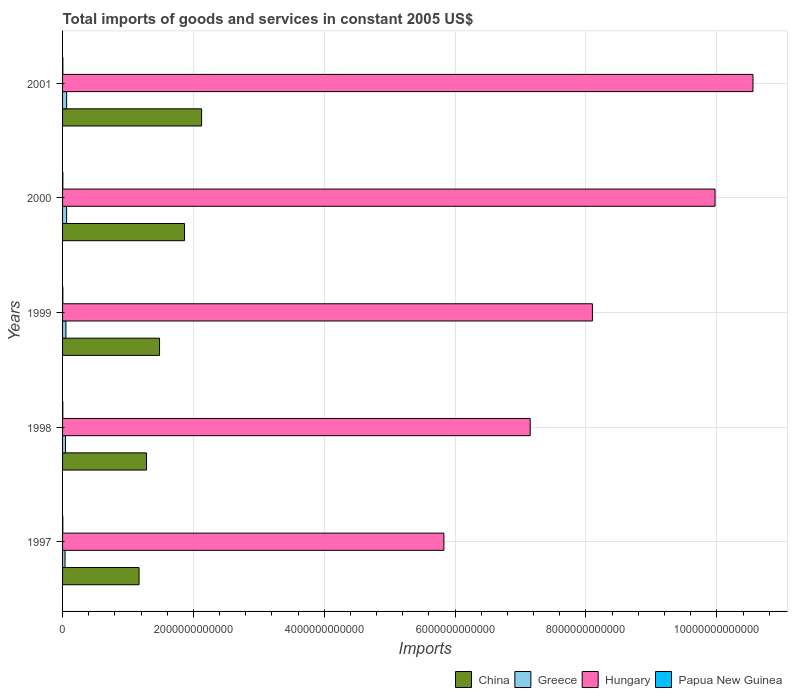How many different coloured bars are there?
Ensure brevity in your answer.  4. Are the number of bars on each tick of the Y-axis equal?
Offer a terse response. Yes. How many bars are there on the 2nd tick from the top?
Offer a very short reply. 4. How many bars are there on the 3rd tick from the bottom?
Ensure brevity in your answer.  4. What is the label of the 5th group of bars from the top?
Give a very brief answer. 1997. In how many cases, is the number of bars for a given year not equal to the number of legend labels?
Provide a short and direct response. 0. What is the total imports of goods and services in Greece in 2000?
Keep it short and to the point. 6.17e+1. Across all years, what is the maximum total imports of goods and services in Papua New Guinea?
Your response must be concise. 4.48e+09. Across all years, what is the minimum total imports of goods and services in Greece?
Provide a short and direct response. 3.80e+1. In which year was the total imports of goods and services in China maximum?
Make the answer very short. 2001. What is the total total imports of goods and services in Greece in the graph?
Your response must be concise. 2.58e+11. What is the difference between the total imports of goods and services in Papua New Guinea in 1998 and that in 2000?
Give a very brief answer. -3.27e+08. What is the difference between the total imports of goods and services in Papua New Guinea in 1998 and the total imports of goods and services in China in 2001?
Your response must be concise. -2.12e+12. What is the average total imports of goods and services in China per year?
Make the answer very short. 1.58e+12. In the year 2000, what is the difference between the total imports of goods and services in Hungary and total imports of goods and services in Greece?
Your response must be concise. 9.91e+12. What is the ratio of the total imports of goods and services in Hungary in 1999 to that in 2000?
Provide a short and direct response. 0.81. Is the total imports of goods and services in Papua New Guinea in 1998 less than that in 1999?
Provide a short and direct response. Yes. What is the difference between the highest and the second highest total imports of goods and services in Greece?
Offer a terse response. 6.12e+08. What is the difference between the highest and the lowest total imports of goods and services in Hungary?
Keep it short and to the point. 4.72e+12. Is it the case that in every year, the sum of the total imports of goods and services in Hungary and total imports of goods and services in Papua New Guinea is greater than the sum of total imports of goods and services in China and total imports of goods and services in Greece?
Provide a short and direct response. Yes. What does the 2nd bar from the top in 2001 represents?
Provide a succinct answer. Hungary. How many bars are there?
Your answer should be compact. 20. Are all the bars in the graph horizontal?
Give a very brief answer. Yes. How many years are there in the graph?
Offer a terse response. 5. What is the difference between two consecutive major ticks on the X-axis?
Make the answer very short. 2.00e+12. What is the title of the graph?
Ensure brevity in your answer.  Total imports of goods and services in constant 2005 US$. What is the label or title of the X-axis?
Your answer should be very brief. Imports. What is the Imports of China in 1997?
Your response must be concise. 1.17e+12. What is the Imports of Greece in 1997?
Keep it short and to the point. 3.80e+1. What is the Imports in Hungary in 1997?
Ensure brevity in your answer.  5.83e+12. What is the Imports in Papua New Guinea in 1997?
Your response must be concise. 3.80e+09. What is the Imports of China in 1998?
Ensure brevity in your answer.  1.28e+12. What is the Imports in Greece in 1998?
Provide a succinct answer. 4.49e+1. What is the Imports in Hungary in 1998?
Make the answer very short. 7.15e+12. What is the Imports in Papua New Guinea in 1998?
Keep it short and to the point. 3.81e+09. What is the Imports of China in 1999?
Make the answer very short. 1.48e+12. What is the Imports of Greece in 1999?
Your response must be concise. 5.14e+1. What is the Imports in Hungary in 1999?
Your answer should be compact. 8.10e+12. What is the Imports of Papua New Guinea in 1999?
Make the answer very short. 4.34e+09. What is the Imports of China in 2000?
Keep it short and to the point. 1.86e+12. What is the Imports of Greece in 2000?
Give a very brief answer. 6.17e+1. What is the Imports of Hungary in 2000?
Your answer should be very brief. 9.97e+12. What is the Imports in Papua New Guinea in 2000?
Offer a terse response. 4.14e+09. What is the Imports of China in 2001?
Your response must be concise. 2.13e+12. What is the Imports of Greece in 2001?
Give a very brief answer. 6.24e+1. What is the Imports in Hungary in 2001?
Make the answer very short. 1.06e+13. What is the Imports in Papua New Guinea in 2001?
Offer a terse response. 4.48e+09. Across all years, what is the maximum Imports of China?
Provide a short and direct response. 2.13e+12. Across all years, what is the maximum Imports in Greece?
Your answer should be compact. 6.24e+1. Across all years, what is the maximum Imports of Hungary?
Give a very brief answer. 1.06e+13. Across all years, what is the maximum Imports in Papua New Guinea?
Your answer should be very brief. 4.48e+09. Across all years, what is the minimum Imports in China?
Give a very brief answer. 1.17e+12. Across all years, what is the minimum Imports of Greece?
Make the answer very short. 3.80e+1. Across all years, what is the minimum Imports of Hungary?
Your response must be concise. 5.83e+12. Across all years, what is the minimum Imports in Papua New Guinea?
Provide a short and direct response. 3.80e+09. What is the total Imports of China in the graph?
Make the answer very short. 7.92e+12. What is the total Imports in Greece in the graph?
Provide a short and direct response. 2.58e+11. What is the total Imports in Hungary in the graph?
Ensure brevity in your answer.  4.16e+13. What is the total Imports of Papua New Guinea in the graph?
Your answer should be compact. 2.06e+1. What is the difference between the Imports in China in 1997 and that in 1998?
Make the answer very short. -1.14e+11. What is the difference between the Imports in Greece in 1997 and that in 1998?
Give a very brief answer. -6.90e+09. What is the difference between the Imports of Hungary in 1997 and that in 1998?
Your response must be concise. -1.32e+12. What is the difference between the Imports of Papua New Guinea in 1997 and that in 1998?
Your answer should be compact. -1.46e+07. What is the difference between the Imports in China in 1997 and that in 1999?
Ensure brevity in your answer.  -3.13e+11. What is the difference between the Imports in Greece in 1997 and that in 1999?
Make the answer very short. -1.34e+1. What is the difference between the Imports in Hungary in 1997 and that in 1999?
Your response must be concise. -2.27e+12. What is the difference between the Imports of Papua New Guinea in 1997 and that in 1999?
Give a very brief answer. -5.48e+08. What is the difference between the Imports in China in 1997 and that in 2000?
Make the answer very short. -6.94e+11. What is the difference between the Imports in Greece in 1997 and that in 2000?
Offer a terse response. -2.38e+1. What is the difference between the Imports in Hungary in 1997 and that in 2000?
Provide a succinct answer. -4.14e+12. What is the difference between the Imports in Papua New Guinea in 1997 and that in 2000?
Provide a short and direct response. -3.42e+08. What is the difference between the Imports of China in 1997 and that in 2001?
Offer a very short reply. -9.56e+11. What is the difference between the Imports of Greece in 1997 and that in 2001?
Ensure brevity in your answer.  -2.44e+1. What is the difference between the Imports in Hungary in 1997 and that in 2001?
Make the answer very short. -4.72e+12. What is the difference between the Imports of Papua New Guinea in 1997 and that in 2001?
Offer a terse response. -6.84e+08. What is the difference between the Imports in China in 1998 and that in 1999?
Your answer should be compact. -1.99e+11. What is the difference between the Imports in Greece in 1998 and that in 1999?
Make the answer very short. -6.50e+09. What is the difference between the Imports in Hungary in 1998 and that in 1999?
Offer a very short reply. -9.51e+11. What is the difference between the Imports of Papua New Guinea in 1998 and that in 1999?
Provide a succinct answer. -5.34e+08. What is the difference between the Imports of China in 1998 and that in 2000?
Provide a short and direct response. -5.80e+11. What is the difference between the Imports in Greece in 1998 and that in 2000?
Provide a succinct answer. -1.69e+1. What is the difference between the Imports of Hungary in 1998 and that in 2000?
Give a very brief answer. -2.83e+12. What is the difference between the Imports in Papua New Guinea in 1998 and that in 2000?
Give a very brief answer. -3.27e+08. What is the difference between the Imports of China in 1998 and that in 2001?
Give a very brief answer. -8.42e+11. What is the difference between the Imports of Greece in 1998 and that in 2001?
Ensure brevity in your answer.  -1.75e+1. What is the difference between the Imports in Hungary in 1998 and that in 2001?
Make the answer very short. -3.41e+12. What is the difference between the Imports in Papua New Guinea in 1998 and that in 2001?
Offer a very short reply. -6.70e+08. What is the difference between the Imports of China in 1999 and that in 2000?
Make the answer very short. -3.82e+11. What is the difference between the Imports of Greece in 1999 and that in 2000?
Offer a very short reply. -1.04e+1. What is the difference between the Imports in Hungary in 1999 and that in 2000?
Provide a succinct answer. -1.87e+12. What is the difference between the Imports of Papua New Guinea in 1999 and that in 2000?
Keep it short and to the point. 2.06e+08. What is the difference between the Imports of China in 1999 and that in 2001?
Offer a terse response. -6.43e+11. What is the difference between the Imports in Greece in 1999 and that in 2001?
Your answer should be very brief. -1.10e+1. What is the difference between the Imports of Hungary in 1999 and that in 2001?
Offer a very short reply. -2.45e+12. What is the difference between the Imports in Papua New Guinea in 1999 and that in 2001?
Offer a terse response. -1.36e+08. What is the difference between the Imports in China in 2000 and that in 2001?
Offer a terse response. -2.61e+11. What is the difference between the Imports of Greece in 2000 and that in 2001?
Offer a terse response. -6.12e+08. What is the difference between the Imports of Hungary in 2000 and that in 2001?
Make the answer very short. -5.80e+11. What is the difference between the Imports in Papua New Guinea in 2000 and that in 2001?
Provide a short and direct response. -3.42e+08. What is the difference between the Imports in China in 1997 and the Imports in Greece in 1998?
Your answer should be very brief. 1.12e+12. What is the difference between the Imports in China in 1997 and the Imports in Hungary in 1998?
Provide a succinct answer. -5.98e+12. What is the difference between the Imports of China in 1997 and the Imports of Papua New Guinea in 1998?
Provide a short and direct response. 1.17e+12. What is the difference between the Imports in Greece in 1997 and the Imports in Hungary in 1998?
Ensure brevity in your answer.  -7.11e+12. What is the difference between the Imports in Greece in 1997 and the Imports in Papua New Guinea in 1998?
Your answer should be compact. 3.42e+1. What is the difference between the Imports of Hungary in 1997 and the Imports of Papua New Guinea in 1998?
Your response must be concise. 5.82e+12. What is the difference between the Imports of China in 1997 and the Imports of Greece in 1999?
Provide a succinct answer. 1.12e+12. What is the difference between the Imports of China in 1997 and the Imports of Hungary in 1999?
Offer a very short reply. -6.93e+12. What is the difference between the Imports of China in 1997 and the Imports of Papua New Guinea in 1999?
Offer a terse response. 1.17e+12. What is the difference between the Imports of Greece in 1997 and the Imports of Hungary in 1999?
Give a very brief answer. -8.06e+12. What is the difference between the Imports in Greece in 1997 and the Imports in Papua New Guinea in 1999?
Offer a terse response. 3.36e+1. What is the difference between the Imports in Hungary in 1997 and the Imports in Papua New Guinea in 1999?
Ensure brevity in your answer.  5.82e+12. What is the difference between the Imports of China in 1997 and the Imports of Greece in 2000?
Your answer should be compact. 1.11e+12. What is the difference between the Imports in China in 1997 and the Imports in Hungary in 2000?
Offer a terse response. -8.80e+12. What is the difference between the Imports in China in 1997 and the Imports in Papua New Guinea in 2000?
Offer a very short reply. 1.17e+12. What is the difference between the Imports of Greece in 1997 and the Imports of Hungary in 2000?
Your answer should be very brief. -9.93e+12. What is the difference between the Imports in Greece in 1997 and the Imports in Papua New Guinea in 2000?
Provide a short and direct response. 3.38e+1. What is the difference between the Imports of Hungary in 1997 and the Imports of Papua New Guinea in 2000?
Your answer should be compact. 5.82e+12. What is the difference between the Imports of China in 1997 and the Imports of Greece in 2001?
Offer a very short reply. 1.11e+12. What is the difference between the Imports of China in 1997 and the Imports of Hungary in 2001?
Your answer should be compact. -9.38e+12. What is the difference between the Imports of China in 1997 and the Imports of Papua New Guinea in 2001?
Your response must be concise. 1.17e+12. What is the difference between the Imports in Greece in 1997 and the Imports in Hungary in 2001?
Ensure brevity in your answer.  -1.05e+13. What is the difference between the Imports of Greece in 1997 and the Imports of Papua New Guinea in 2001?
Your response must be concise. 3.35e+1. What is the difference between the Imports in Hungary in 1997 and the Imports in Papua New Guinea in 2001?
Ensure brevity in your answer.  5.82e+12. What is the difference between the Imports of China in 1998 and the Imports of Greece in 1999?
Make the answer very short. 1.23e+12. What is the difference between the Imports in China in 1998 and the Imports in Hungary in 1999?
Offer a very short reply. -6.81e+12. What is the difference between the Imports of China in 1998 and the Imports of Papua New Guinea in 1999?
Offer a terse response. 1.28e+12. What is the difference between the Imports in Greece in 1998 and the Imports in Hungary in 1999?
Make the answer very short. -8.05e+12. What is the difference between the Imports in Greece in 1998 and the Imports in Papua New Guinea in 1999?
Ensure brevity in your answer.  4.05e+1. What is the difference between the Imports of Hungary in 1998 and the Imports of Papua New Guinea in 1999?
Provide a succinct answer. 7.14e+12. What is the difference between the Imports in China in 1998 and the Imports in Greece in 2000?
Offer a terse response. 1.22e+12. What is the difference between the Imports of China in 1998 and the Imports of Hungary in 2000?
Ensure brevity in your answer.  -8.69e+12. What is the difference between the Imports in China in 1998 and the Imports in Papua New Guinea in 2000?
Your response must be concise. 1.28e+12. What is the difference between the Imports in Greece in 1998 and the Imports in Hungary in 2000?
Your answer should be compact. -9.93e+12. What is the difference between the Imports in Greece in 1998 and the Imports in Papua New Guinea in 2000?
Your response must be concise. 4.07e+1. What is the difference between the Imports in Hungary in 1998 and the Imports in Papua New Guinea in 2000?
Make the answer very short. 7.14e+12. What is the difference between the Imports in China in 1998 and the Imports in Greece in 2001?
Make the answer very short. 1.22e+12. What is the difference between the Imports of China in 1998 and the Imports of Hungary in 2001?
Your answer should be very brief. -9.27e+12. What is the difference between the Imports in China in 1998 and the Imports in Papua New Guinea in 2001?
Offer a terse response. 1.28e+12. What is the difference between the Imports of Greece in 1998 and the Imports of Hungary in 2001?
Give a very brief answer. -1.05e+13. What is the difference between the Imports in Greece in 1998 and the Imports in Papua New Guinea in 2001?
Offer a very short reply. 4.04e+1. What is the difference between the Imports of Hungary in 1998 and the Imports of Papua New Guinea in 2001?
Keep it short and to the point. 7.14e+12. What is the difference between the Imports of China in 1999 and the Imports of Greece in 2000?
Offer a terse response. 1.42e+12. What is the difference between the Imports in China in 1999 and the Imports in Hungary in 2000?
Provide a succinct answer. -8.49e+12. What is the difference between the Imports in China in 1999 and the Imports in Papua New Guinea in 2000?
Keep it short and to the point. 1.48e+12. What is the difference between the Imports in Greece in 1999 and the Imports in Hungary in 2000?
Your response must be concise. -9.92e+12. What is the difference between the Imports of Greece in 1999 and the Imports of Papua New Guinea in 2000?
Keep it short and to the point. 4.72e+1. What is the difference between the Imports of Hungary in 1999 and the Imports of Papua New Guinea in 2000?
Give a very brief answer. 8.09e+12. What is the difference between the Imports in China in 1999 and the Imports in Greece in 2001?
Keep it short and to the point. 1.42e+12. What is the difference between the Imports in China in 1999 and the Imports in Hungary in 2001?
Your answer should be compact. -9.07e+12. What is the difference between the Imports in China in 1999 and the Imports in Papua New Guinea in 2001?
Give a very brief answer. 1.48e+12. What is the difference between the Imports of Greece in 1999 and the Imports of Hungary in 2001?
Give a very brief answer. -1.05e+13. What is the difference between the Imports in Greece in 1999 and the Imports in Papua New Guinea in 2001?
Keep it short and to the point. 4.69e+1. What is the difference between the Imports of Hungary in 1999 and the Imports of Papua New Guinea in 2001?
Your answer should be very brief. 8.09e+12. What is the difference between the Imports of China in 2000 and the Imports of Greece in 2001?
Ensure brevity in your answer.  1.80e+12. What is the difference between the Imports of China in 2000 and the Imports of Hungary in 2001?
Make the answer very short. -8.69e+12. What is the difference between the Imports in China in 2000 and the Imports in Papua New Guinea in 2001?
Make the answer very short. 1.86e+12. What is the difference between the Imports of Greece in 2000 and the Imports of Hungary in 2001?
Keep it short and to the point. -1.05e+13. What is the difference between the Imports of Greece in 2000 and the Imports of Papua New Guinea in 2001?
Provide a short and direct response. 5.73e+1. What is the difference between the Imports of Hungary in 2000 and the Imports of Papua New Guinea in 2001?
Your answer should be very brief. 9.97e+12. What is the average Imports in China per year?
Your answer should be compact. 1.58e+12. What is the average Imports of Greece per year?
Offer a very short reply. 5.17e+1. What is the average Imports of Hungary per year?
Keep it short and to the point. 8.32e+12. What is the average Imports in Papua New Guinea per year?
Your answer should be compact. 4.11e+09. In the year 1997, what is the difference between the Imports of China and Imports of Greece?
Provide a short and direct response. 1.13e+12. In the year 1997, what is the difference between the Imports in China and Imports in Hungary?
Your answer should be very brief. -4.66e+12. In the year 1997, what is the difference between the Imports of China and Imports of Papua New Guinea?
Make the answer very short. 1.17e+12. In the year 1997, what is the difference between the Imports in Greece and Imports in Hungary?
Keep it short and to the point. -5.79e+12. In the year 1997, what is the difference between the Imports of Greece and Imports of Papua New Guinea?
Provide a short and direct response. 3.42e+1. In the year 1997, what is the difference between the Imports of Hungary and Imports of Papua New Guinea?
Offer a very short reply. 5.82e+12. In the year 1998, what is the difference between the Imports of China and Imports of Greece?
Offer a very short reply. 1.24e+12. In the year 1998, what is the difference between the Imports of China and Imports of Hungary?
Make the answer very short. -5.86e+12. In the year 1998, what is the difference between the Imports in China and Imports in Papua New Guinea?
Your answer should be compact. 1.28e+12. In the year 1998, what is the difference between the Imports of Greece and Imports of Hungary?
Make the answer very short. -7.10e+12. In the year 1998, what is the difference between the Imports of Greece and Imports of Papua New Guinea?
Provide a succinct answer. 4.11e+1. In the year 1998, what is the difference between the Imports in Hungary and Imports in Papua New Guinea?
Keep it short and to the point. 7.14e+12. In the year 1999, what is the difference between the Imports of China and Imports of Greece?
Your answer should be compact. 1.43e+12. In the year 1999, what is the difference between the Imports in China and Imports in Hungary?
Your answer should be compact. -6.62e+12. In the year 1999, what is the difference between the Imports of China and Imports of Papua New Guinea?
Provide a succinct answer. 1.48e+12. In the year 1999, what is the difference between the Imports of Greece and Imports of Hungary?
Make the answer very short. -8.05e+12. In the year 1999, what is the difference between the Imports in Greece and Imports in Papua New Guinea?
Offer a terse response. 4.70e+1. In the year 1999, what is the difference between the Imports in Hungary and Imports in Papua New Guinea?
Your answer should be very brief. 8.09e+12. In the year 2000, what is the difference between the Imports in China and Imports in Greece?
Make the answer very short. 1.80e+12. In the year 2000, what is the difference between the Imports of China and Imports of Hungary?
Give a very brief answer. -8.11e+12. In the year 2000, what is the difference between the Imports in China and Imports in Papua New Guinea?
Give a very brief answer. 1.86e+12. In the year 2000, what is the difference between the Imports in Greece and Imports in Hungary?
Give a very brief answer. -9.91e+12. In the year 2000, what is the difference between the Imports in Greece and Imports in Papua New Guinea?
Ensure brevity in your answer.  5.76e+1. In the year 2000, what is the difference between the Imports of Hungary and Imports of Papua New Guinea?
Your response must be concise. 9.97e+12. In the year 2001, what is the difference between the Imports of China and Imports of Greece?
Provide a succinct answer. 2.06e+12. In the year 2001, what is the difference between the Imports of China and Imports of Hungary?
Offer a terse response. -8.43e+12. In the year 2001, what is the difference between the Imports of China and Imports of Papua New Guinea?
Your response must be concise. 2.12e+12. In the year 2001, what is the difference between the Imports in Greece and Imports in Hungary?
Offer a very short reply. -1.05e+13. In the year 2001, what is the difference between the Imports of Greece and Imports of Papua New Guinea?
Ensure brevity in your answer.  5.79e+1. In the year 2001, what is the difference between the Imports in Hungary and Imports in Papua New Guinea?
Your answer should be compact. 1.05e+13. What is the ratio of the Imports of China in 1997 to that in 1998?
Offer a terse response. 0.91. What is the ratio of the Imports of Greece in 1997 to that in 1998?
Ensure brevity in your answer.  0.85. What is the ratio of the Imports in Hungary in 1997 to that in 1998?
Offer a terse response. 0.82. What is the ratio of the Imports of China in 1997 to that in 1999?
Your response must be concise. 0.79. What is the ratio of the Imports in Greece in 1997 to that in 1999?
Your answer should be very brief. 0.74. What is the ratio of the Imports of Hungary in 1997 to that in 1999?
Your answer should be compact. 0.72. What is the ratio of the Imports in Papua New Guinea in 1997 to that in 1999?
Give a very brief answer. 0.87. What is the ratio of the Imports in China in 1997 to that in 2000?
Provide a succinct answer. 0.63. What is the ratio of the Imports in Greece in 1997 to that in 2000?
Provide a short and direct response. 0.62. What is the ratio of the Imports in Hungary in 1997 to that in 2000?
Your answer should be very brief. 0.58. What is the ratio of the Imports in Papua New Guinea in 1997 to that in 2000?
Give a very brief answer. 0.92. What is the ratio of the Imports of China in 1997 to that in 2001?
Offer a very short reply. 0.55. What is the ratio of the Imports of Greece in 1997 to that in 2001?
Give a very brief answer. 0.61. What is the ratio of the Imports in Hungary in 1997 to that in 2001?
Make the answer very short. 0.55. What is the ratio of the Imports in Papua New Guinea in 1997 to that in 2001?
Keep it short and to the point. 0.85. What is the ratio of the Imports of China in 1998 to that in 1999?
Give a very brief answer. 0.87. What is the ratio of the Imports in Greece in 1998 to that in 1999?
Keep it short and to the point. 0.87. What is the ratio of the Imports of Hungary in 1998 to that in 1999?
Provide a succinct answer. 0.88. What is the ratio of the Imports of Papua New Guinea in 1998 to that in 1999?
Ensure brevity in your answer.  0.88. What is the ratio of the Imports of China in 1998 to that in 2000?
Your answer should be very brief. 0.69. What is the ratio of the Imports in Greece in 1998 to that in 2000?
Keep it short and to the point. 0.73. What is the ratio of the Imports of Hungary in 1998 to that in 2000?
Provide a short and direct response. 0.72. What is the ratio of the Imports in Papua New Guinea in 1998 to that in 2000?
Keep it short and to the point. 0.92. What is the ratio of the Imports of China in 1998 to that in 2001?
Ensure brevity in your answer.  0.6. What is the ratio of the Imports in Greece in 1998 to that in 2001?
Make the answer very short. 0.72. What is the ratio of the Imports of Hungary in 1998 to that in 2001?
Offer a terse response. 0.68. What is the ratio of the Imports in Papua New Guinea in 1998 to that in 2001?
Give a very brief answer. 0.85. What is the ratio of the Imports in China in 1999 to that in 2000?
Offer a very short reply. 0.8. What is the ratio of the Imports of Greece in 1999 to that in 2000?
Give a very brief answer. 0.83. What is the ratio of the Imports of Hungary in 1999 to that in 2000?
Ensure brevity in your answer.  0.81. What is the ratio of the Imports of Papua New Guinea in 1999 to that in 2000?
Offer a terse response. 1.05. What is the ratio of the Imports in China in 1999 to that in 2001?
Your answer should be compact. 0.7. What is the ratio of the Imports of Greece in 1999 to that in 2001?
Give a very brief answer. 0.82. What is the ratio of the Imports in Hungary in 1999 to that in 2001?
Ensure brevity in your answer.  0.77. What is the ratio of the Imports in Papua New Guinea in 1999 to that in 2001?
Ensure brevity in your answer.  0.97. What is the ratio of the Imports of China in 2000 to that in 2001?
Your response must be concise. 0.88. What is the ratio of the Imports of Greece in 2000 to that in 2001?
Make the answer very short. 0.99. What is the ratio of the Imports of Hungary in 2000 to that in 2001?
Make the answer very short. 0.95. What is the ratio of the Imports of Papua New Guinea in 2000 to that in 2001?
Your answer should be compact. 0.92. What is the difference between the highest and the second highest Imports in China?
Your answer should be very brief. 2.61e+11. What is the difference between the highest and the second highest Imports in Greece?
Make the answer very short. 6.12e+08. What is the difference between the highest and the second highest Imports of Hungary?
Keep it short and to the point. 5.80e+11. What is the difference between the highest and the second highest Imports in Papua New Guinea?
Your response must be concise. 1.36e+08. What is the difference between the highest and the lowest Imports of China?
Offer a terse response. 9.56e+11. What is the difference between the highest and the lowest Imports in Greece?
Your response must be concise. 2.44e+1. What is the difference between the highest and the lowest Imports in Hungary?
Keep it short and to the point. 4.72e+12. What is the difference between the highest and the lowest Imports of Papua New Guinea?
Offer a terse response. 6.84e+08. 